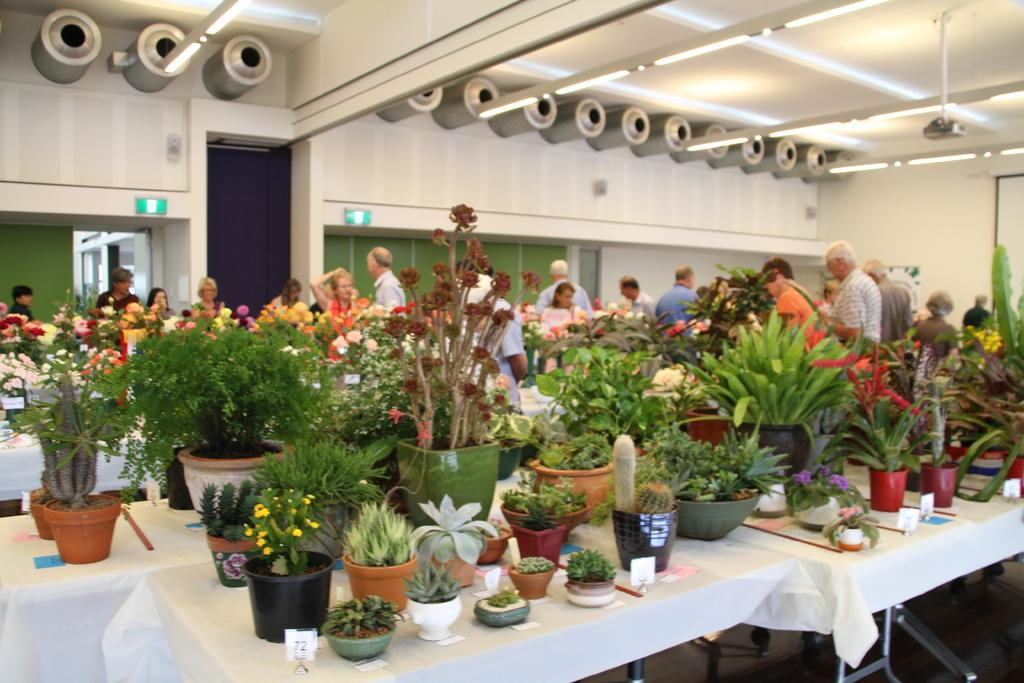What is placed on the tables in the center of the image? There are planets placed on tables in the center of the image. What can be seen in the background of the image? In the background of the image, there are persons, plants, lights, a door, a projector, a screen, and a wall. Can you describe the setting where the planets are placed? The planets are placed on tables in a room with a background that includes various elements such as people, plants, lights, a door, a projector, a screen, and a wall. What is the process of digestion like for the planets in the image? The planets in the image are not living organisms, so they do not have a digestive system or undergo digestion. What type of sky can be seen through the door in the background of the image? There is no sky visible through the door in the background of the image; only a wall is present. 